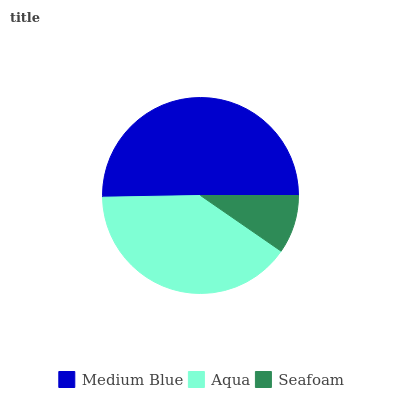Is Seafoam the minimum?
Answer yes or no. Yes. Is Medium Blue the maximum?
Answer yes or no. Yes. Is Aqua the minimum?
Answer yes or no. No. Is Aqua the maximum?
Answer yes or no. No. Is Medium Blue greater than Aqua?
Answer yes or no. Yes. Is Aqua less than Medium Blue?
Answer yes or no. Yes. Is Aqua greater than Medium Blue?
Answer yes or no. No. Is Medium Blue less than Aqua?
Answer yes or no. No. Is Aqua the high median?
Answer yes or no. Yes. Is Aqua the low median?
Answer yes or no. Yes. Is Seafoam the high median?
Answer yes or no. No. Is Medium Blue the low median?
Answer yes or no. No. 